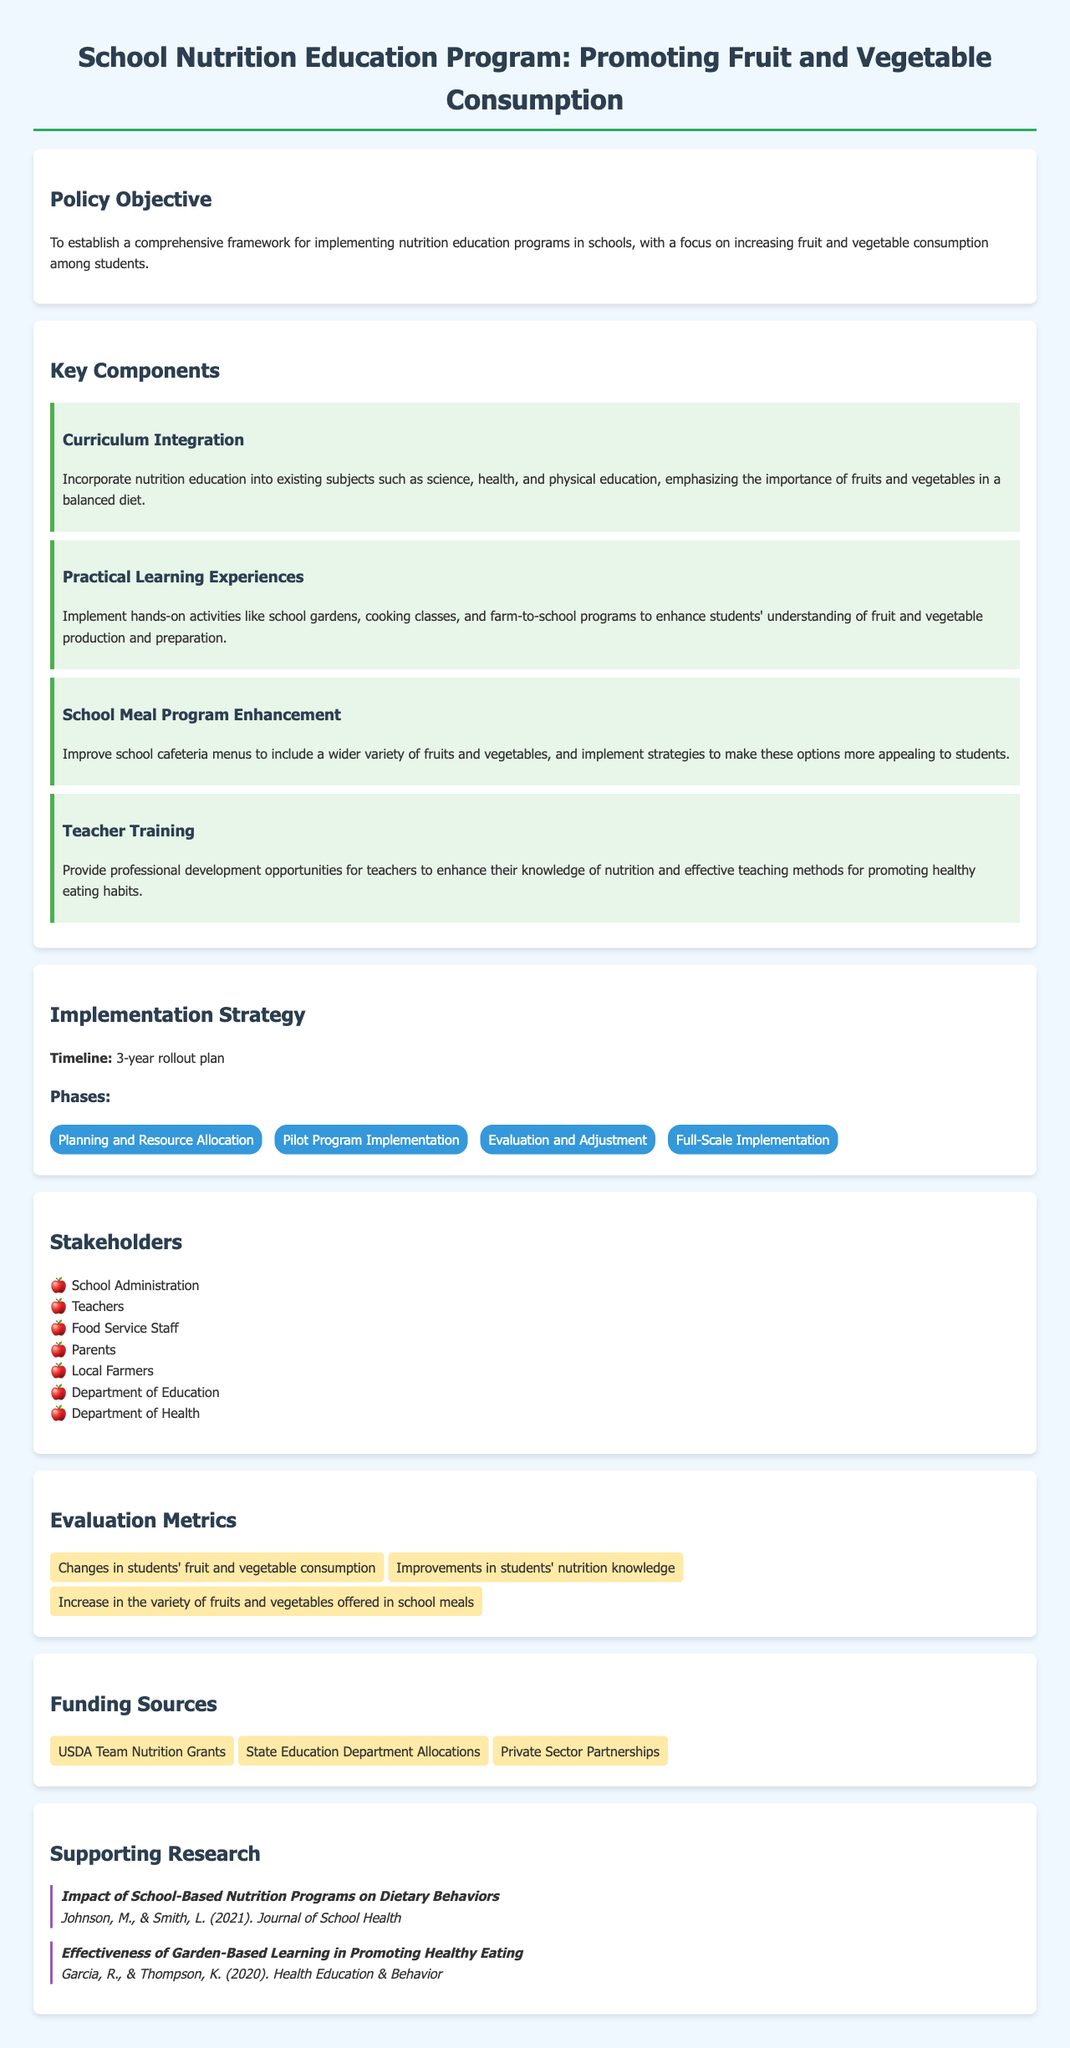What is the policy objective? The policy objective is to establish a comprehensive framework for implementing nutrition education programs in schools, with a focus on increasing fruit and vegetable consumption among students.
Answer: To establish a comprehensive framework for implementing nutrition education programs in schools, with a focus on increasing fruit and vegetable consumption among students What is one of the key components related to teaching methods? One of the key components related to teaching methods is the provision of professional development opportunities for teachers to enhance their knowledge of nutrition and effective teaching methods for promoting healthy eating habits.
Answer: Teacher Training How long is the proposed rollout plan? The proposed rollout plan is stated to be a 3-year rollout plan.
Answer: 3-year Which phase comes after the pilot program implementation? The phase that comes after the pilot program implementation is "Evaluation and Adjustment."
Answer: Evaluation and Adjustment What is one example of a practical learning experience provided in the document? An example of a practical learning experience is the implementation of hands-on activities like school gardens, cooking classes, and farm-to-school programs.
Answer: School gardens What is one funding source mentioned in the document? One funding source mentioned in the document is USDA Team Nutrition Grants.
Answer: USDA Team Nutrition Grants How many stakeholders are listed in the document? The document lists seven stakeholders involved in the program.
Answer: Seven What type of research is supported according to the document? The type of research supported is the impact of school-based nutrition programs on dietary behaviors.
Answer: Impact of School-Based Nutrition Programs on Dietary Behaviors 